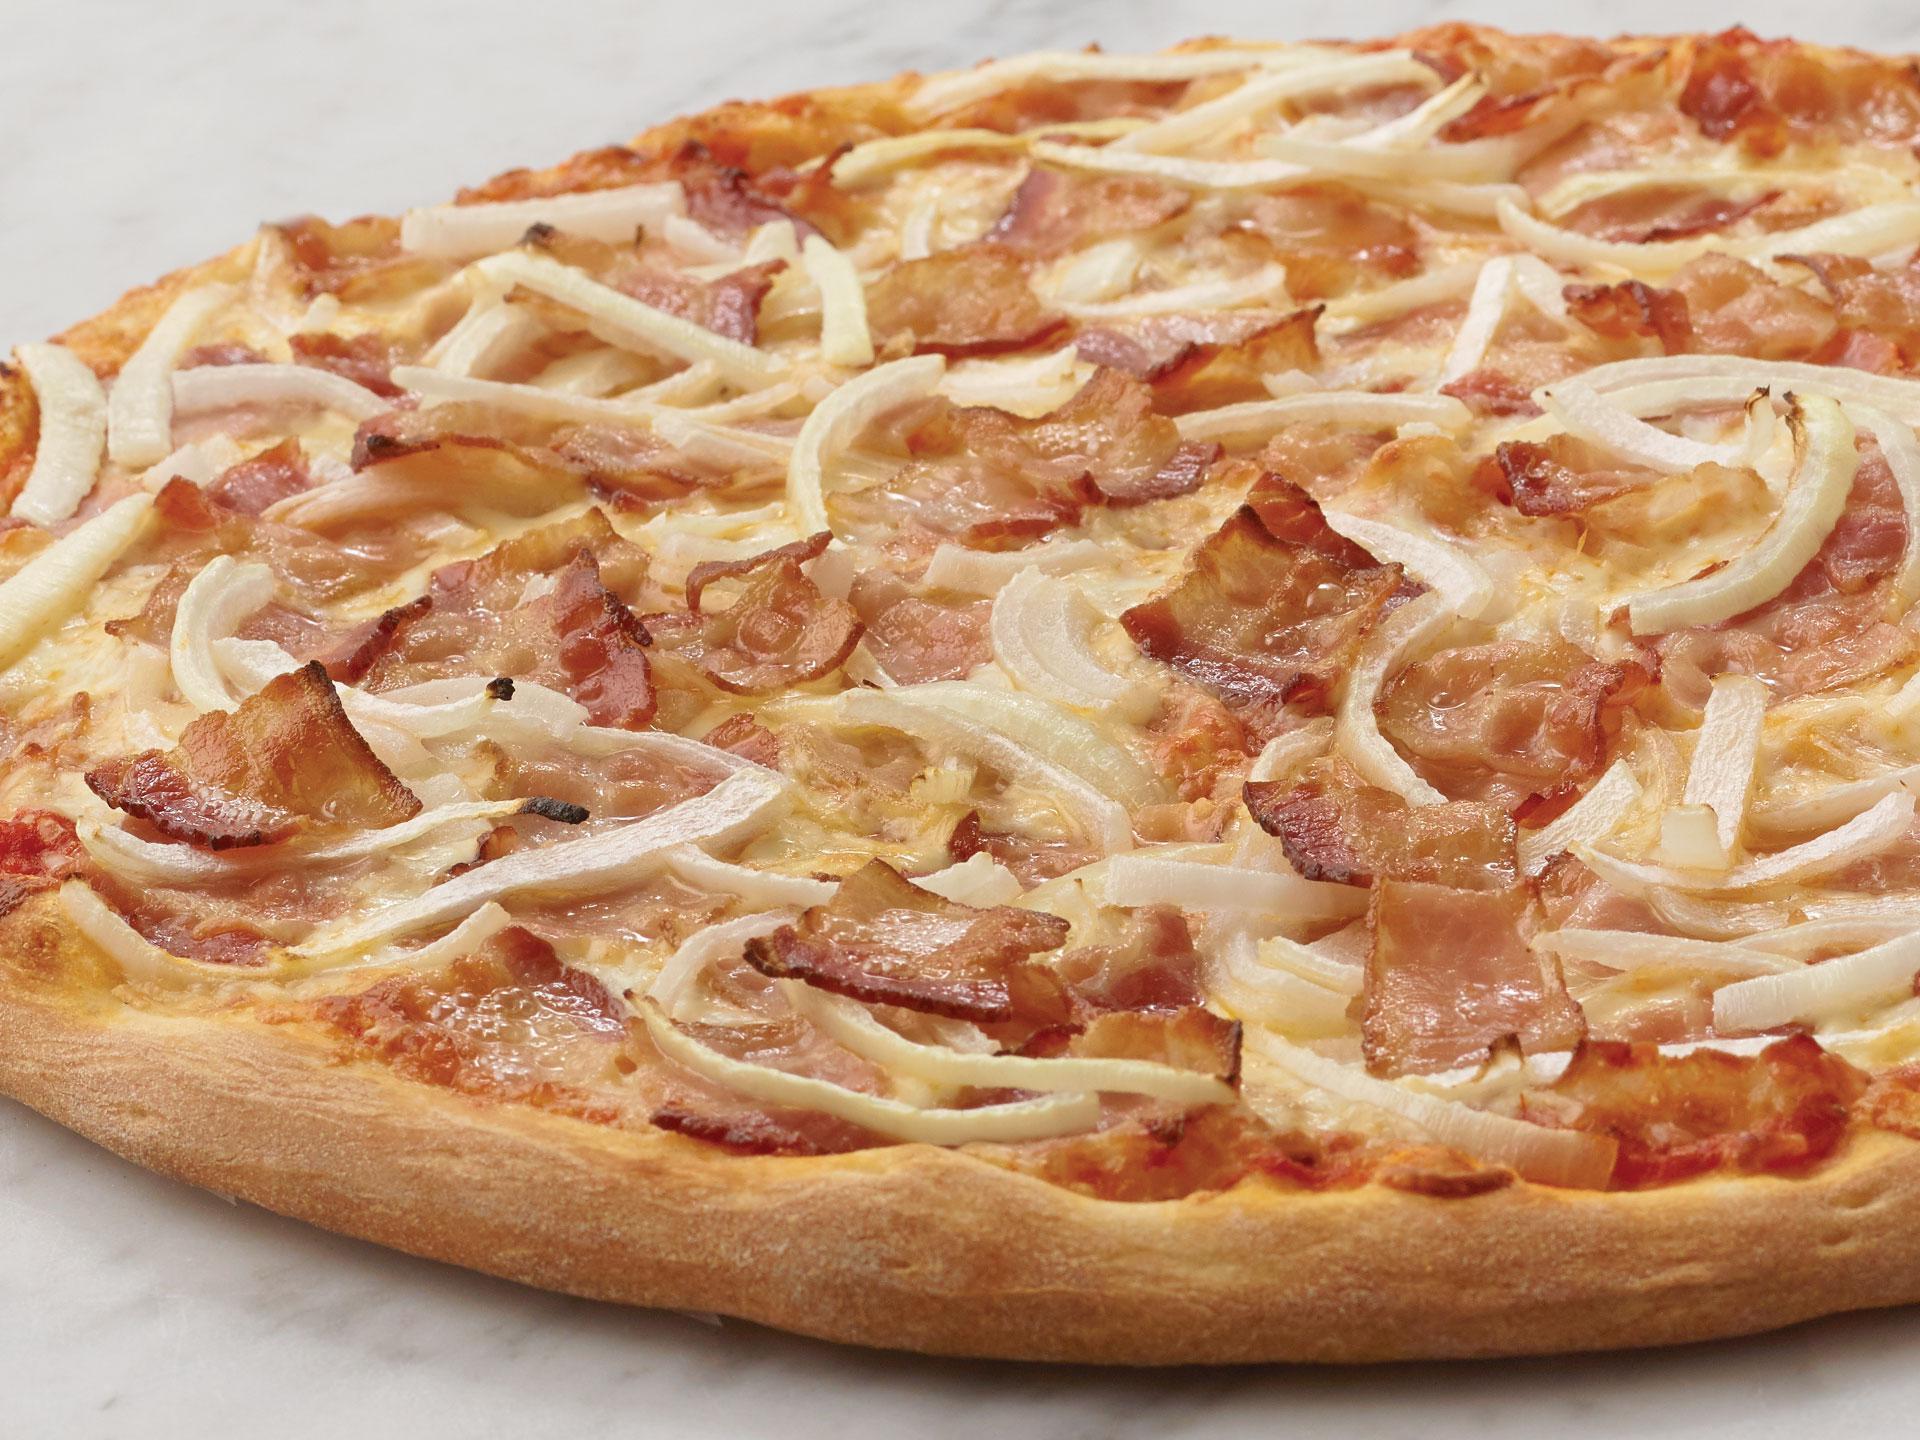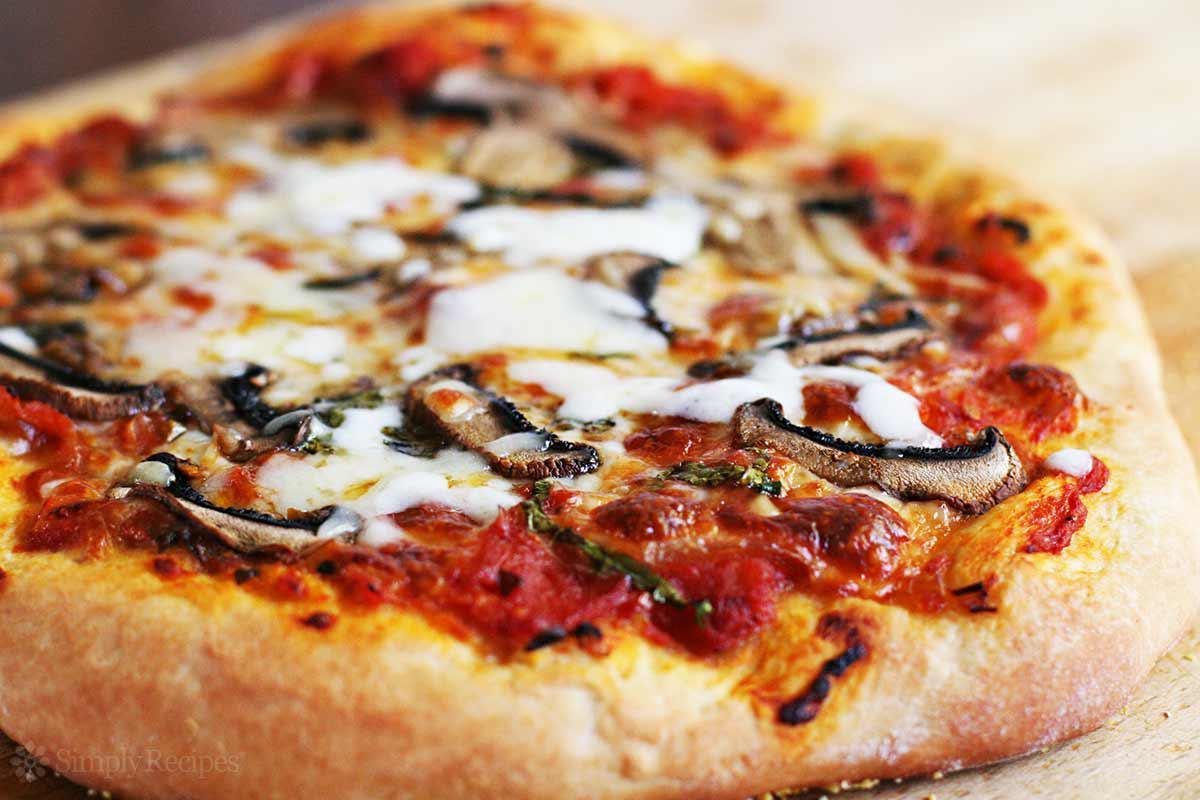The first image is the image on the left, the second image is the image on the right. For the images displayed, is the sentence "There are two circle pizzas." factually correct? Answer yes or no. Yes. The first image is the image on the left, the second image is the image on the right. For the images shown, is this caption "One image shows a pizza with pepperoni as a topping and the other image shows a pizza with no pepperoni." true? Answer yes or no. No. 